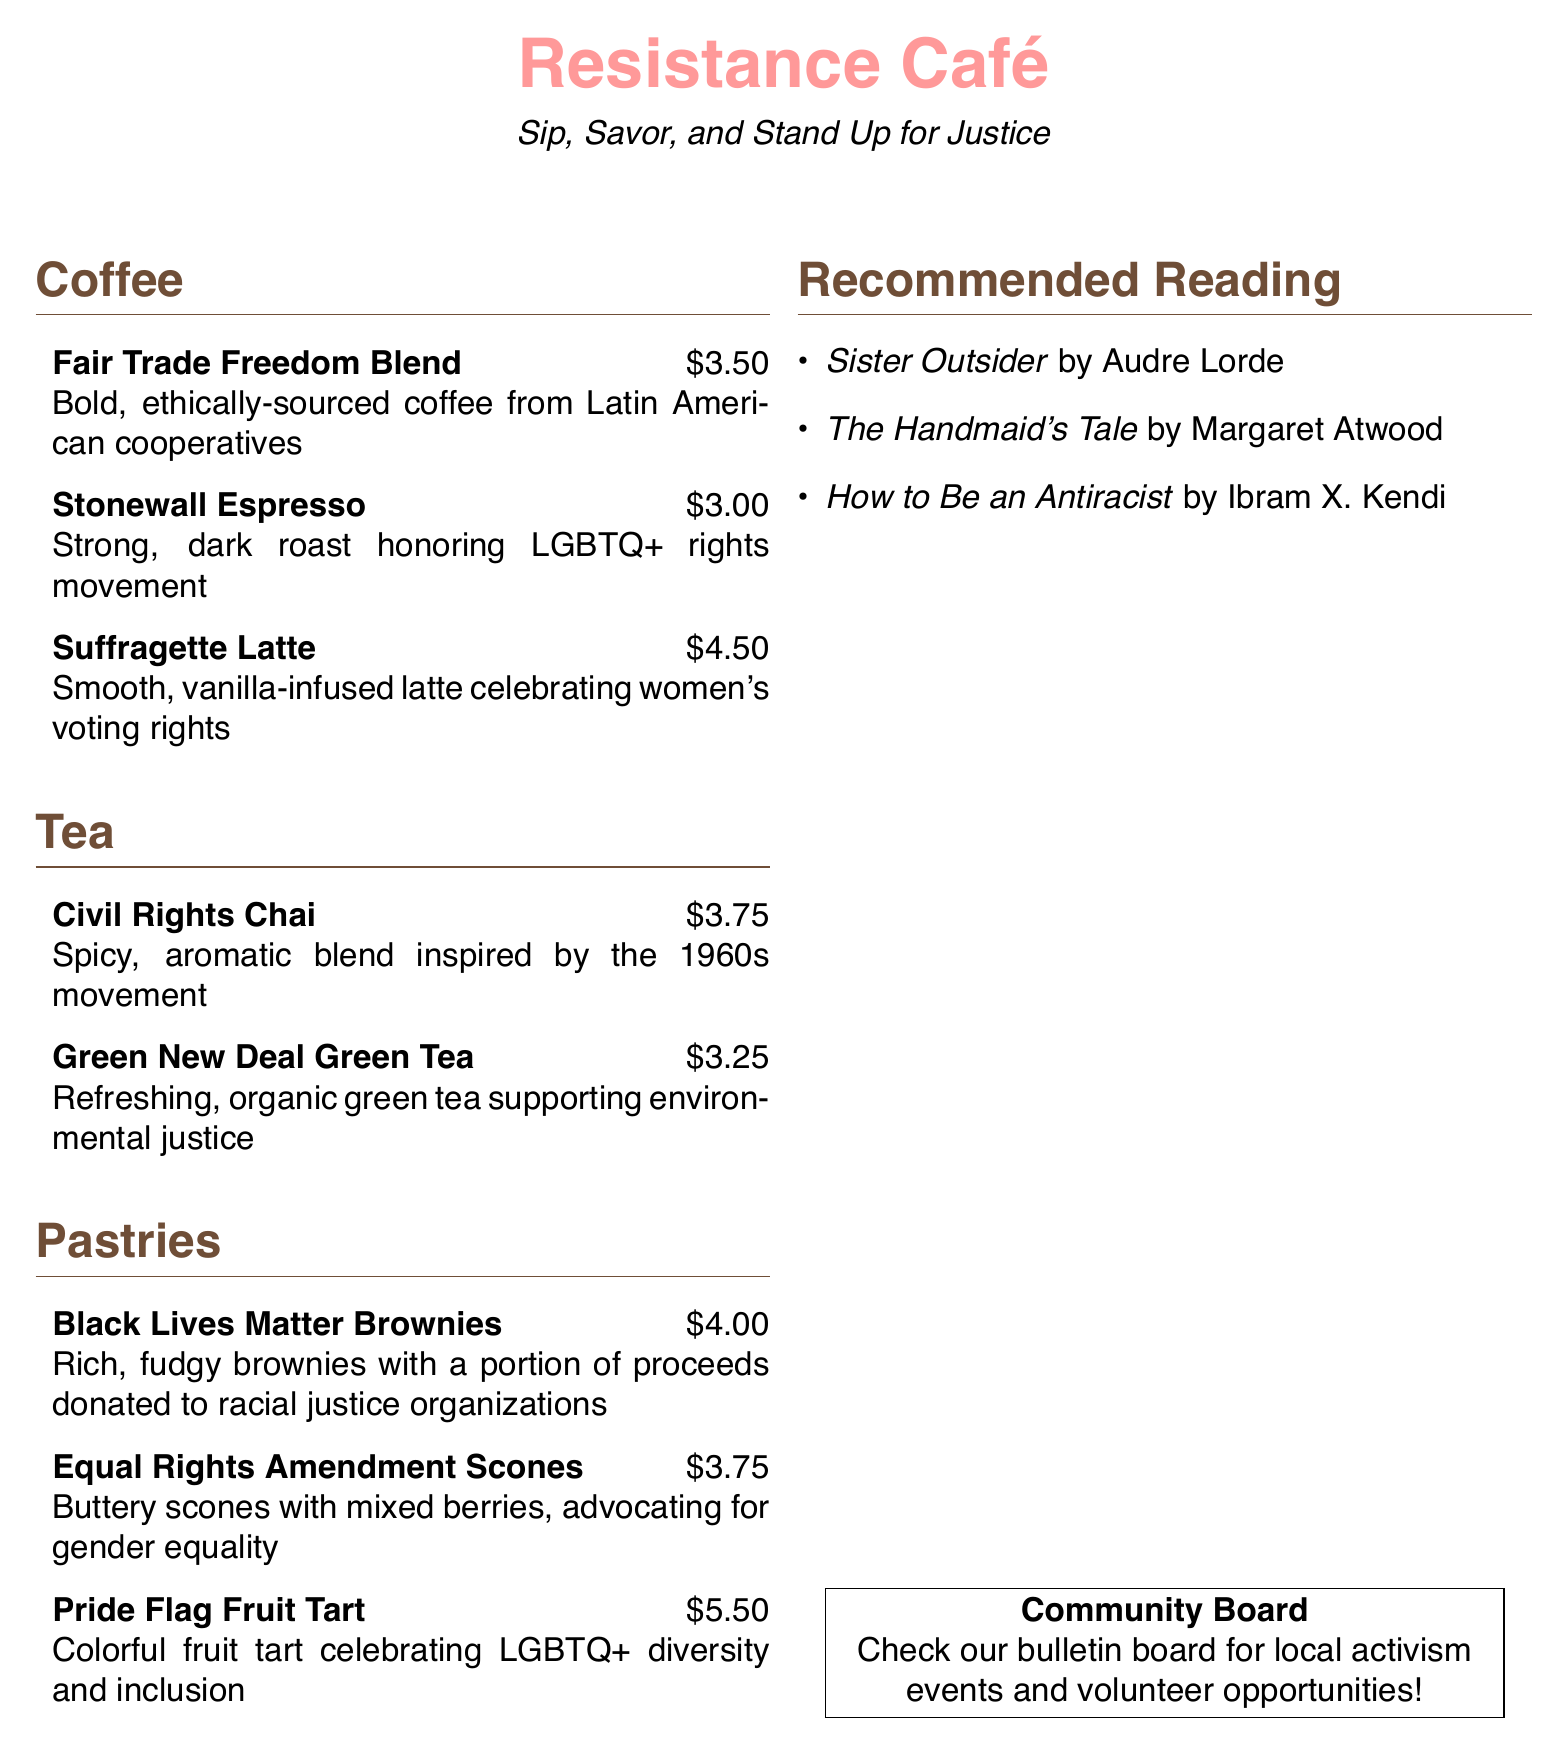What is the price of the Suffragette Latte? The price is listed directly next to the drink on the menu.
Answer: $4.50 What type of tea is inspired by the 1960s movement? The tea type is included in the name and description given in the menu section.
Answer: Civil Rights Chai What are the two ingredients in the Equal Rights Amendment Scones? The ingredients are specified in the item description in the menu.
Answer: Buttery scones with mixed berries Which pastry has proceeds donated to racial justice organizations? This information is found in the description of the pastry.
Answer: Black Lives Matter Brownies How many coffee options are there on the menu? The number of options can be counted directly from the listed items.
Answer: Three What is the title of the recommended reading by Audre Lorde? The title is explicitly mentioned in the reading recommendations section.
Answer: Sister Outsider What motivates the Green New Deal Green Tea? This information is explicitly stated in the tea description.
Answer: Environmental justice Which pastry celebrates LGBTQ+ diversity? The celebration is stated in the name and description of the pastry.
Answer: Pride Flag Fruit Tart 